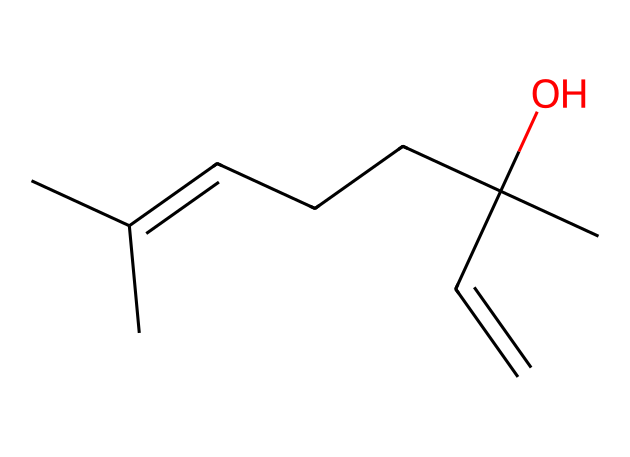How many carbon atoms are in linalool? By analyzing the provided SMILES representation, we count the 'C' characters to find the total number of carbon atoms. The representation shows 10 'C' symbols, indicating there are 10 carbon atoms.
Answer: 10 What functional group is present in linalool? The presence of the hydroxyl group (-OH) indicates that linalool contains an alcohol functional group. In the SMILES, this is represented by 'C(C)(O)', showing the carbon atom connected to an oxygen atom.
Answer: alcohol What is the degree of unsaturation in linalool? The degree of unsaturation can be calculated by identifying double bonds and rings in the structure. Linalool has one double bond (C=C) and no rings, resulting in one degree of unsaturation.
Answer: 1 Which part of linalool contributes to its floral scent? The presence of the hydroxyl group and the double bond, specifically its configuration, contributes to the floral notes in linalool. These features are associated with floral fragrances in chemical compounds.
Answer: hydroxyl group Is linalool a terpenoid? Yes, linalool is classified as a terpenoid due to its molecular structure, which is derived from isoprene units. The analysis of its carbon backbone confirms its classification within this chemical family.
Answer: yes What role does the chiral center play in linalool's properties? The molecule contains a chiral center, which means it can exist in two enantiomeric forms that can have different smells or properties. This affects its sensory profile and potential applications in fragrances.
Answer: enantiomers What is the common use of linalool in the fragrance industry? Linalool is widely used as a fragrance enhancer due to its pleasant floral aroma. It is commonly found in perfumes, soaps, and cosmetics, playing a significant role in creating appealing scents.
Answer: fragrance enhancer 